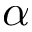<formula> <loc_0><loc_0><loc_500><loc_500>\alpha</formula> 